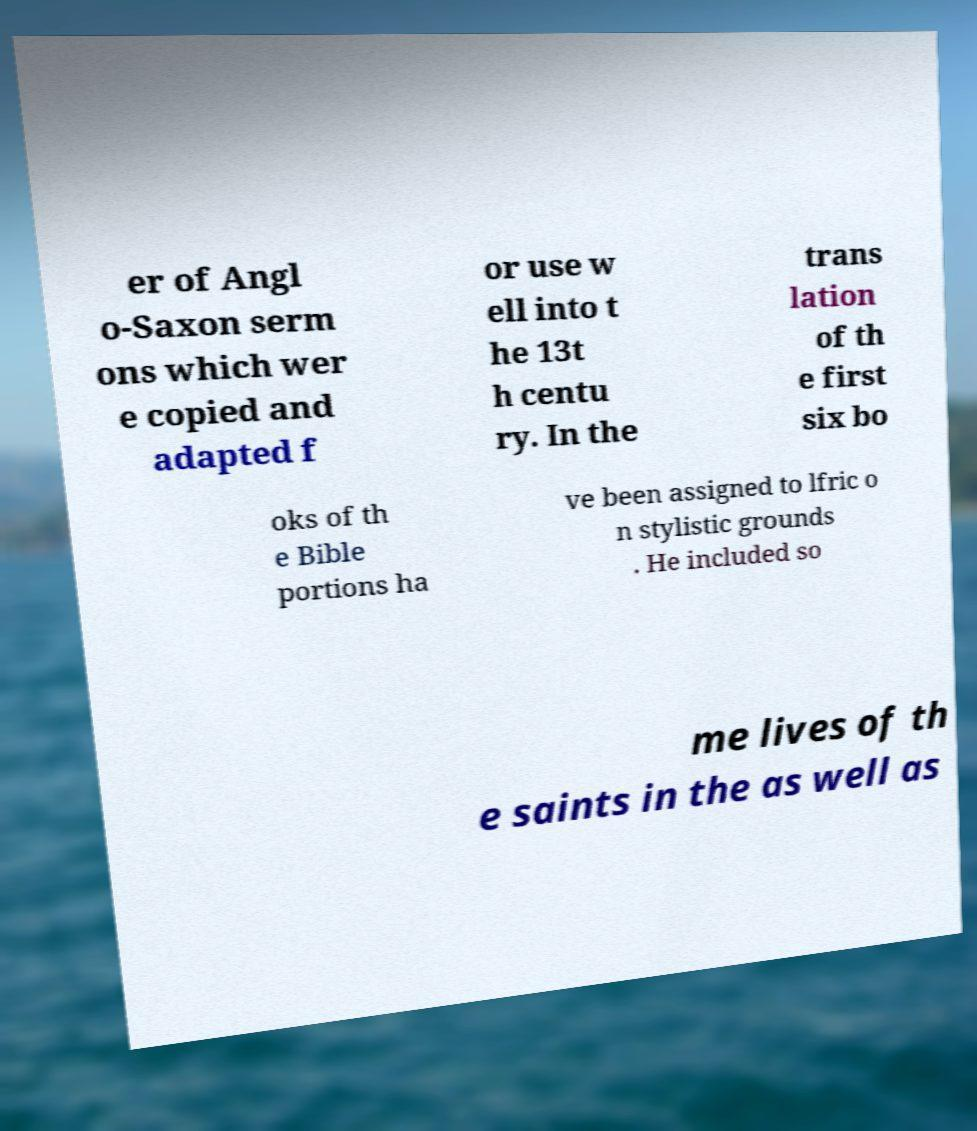Please read and relay the text visible in this image. What does it say? er of Angl o-Saxon serm ons which wer e copied and adapted f or use w ell into t he 13t h centu ry. In the trans lation of th e first six bo oks of th e Bible portions ha ve been assigned to lfric o n stylistic grounds . He included so me lives of th e saints in the as well as 